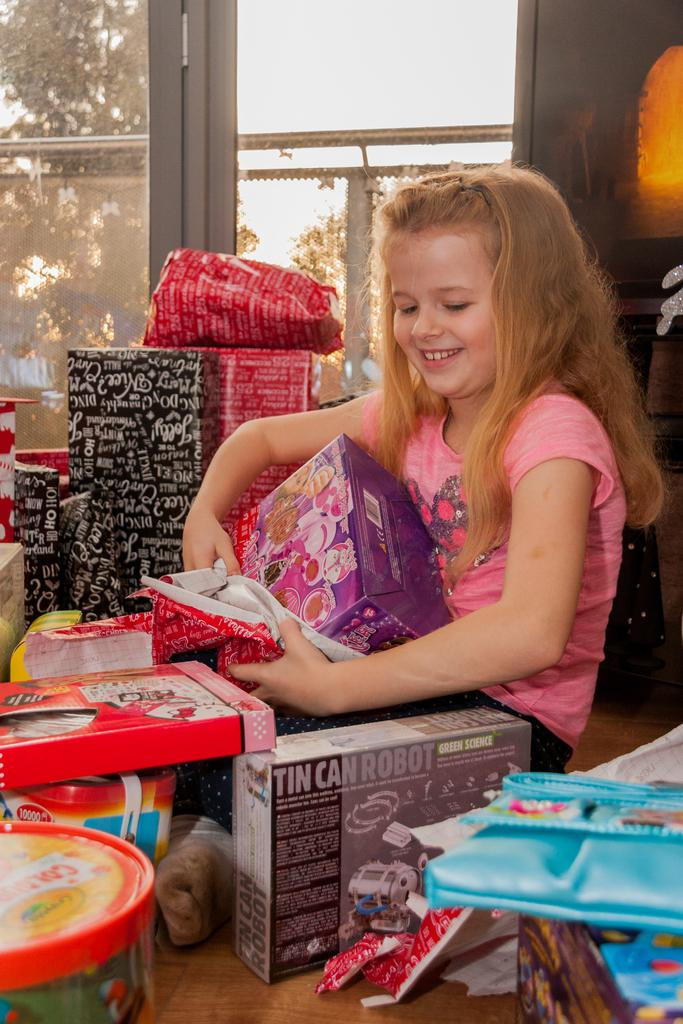What is the girl doing in the image? The girl is sitting on the floor in the image. What items does the girl have with her? The girl has gifts and toys in the image. What can be seen in the background of the image? There is a door, fencing, the sky, and a tree visible in the background of the image. What type of lead is the girl using to make a discovery in the image? There is no lead or discovery activity present in the image. 